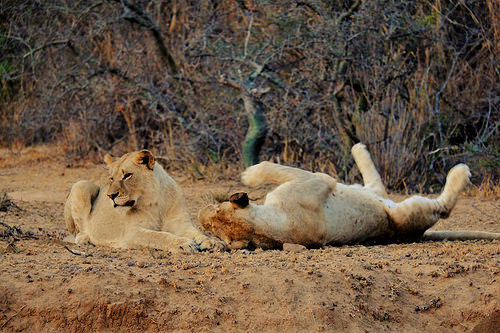<image>
Is there a lion to the right of the tree? No. The lion is not to the right of the tree. The horizontal positioning shows a different relationship. 